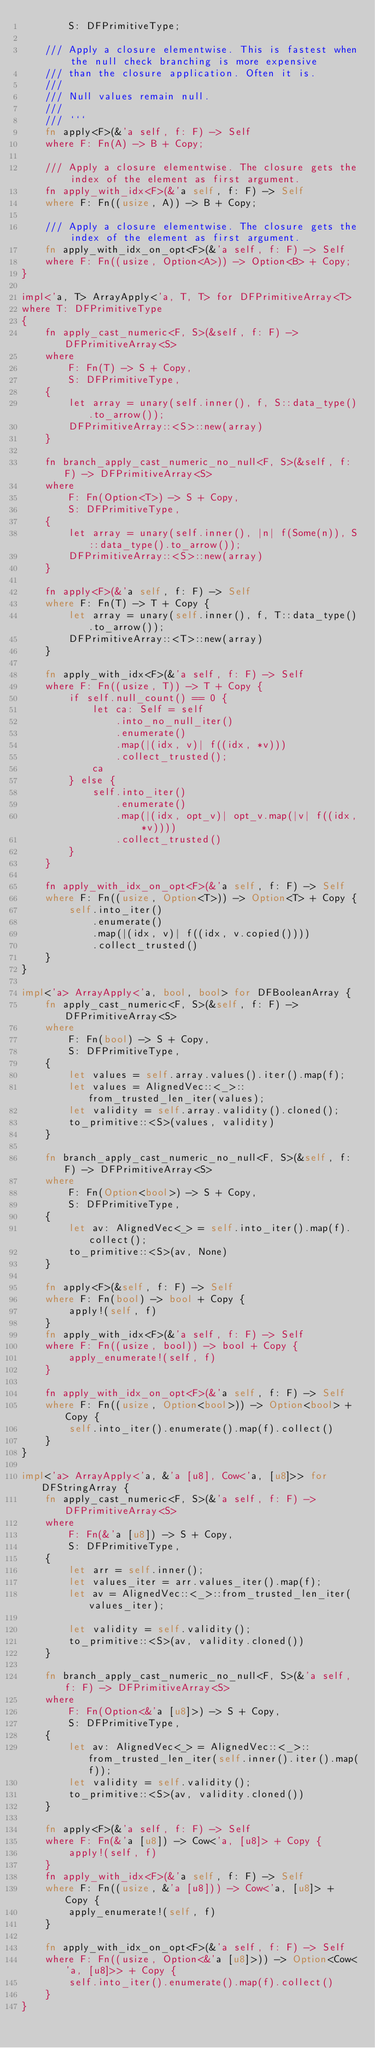<code> <loc_0><loc_0><loc_500><loc_500><_Rust_>        S: DFPrimitiveType;

    /// Apply a closure elementwise. This is fastest when the null check branching is more expensive
    /// than the closure application. Often it is.
    ///
    /// Null values remain null.
    ///
    /// ```
    fn apply<F>(&'a self, f: F) -> Self
    where F: Fn(A) -> B + Copy;

    /// Apply a closure elementwise. The closure gets the index of the element as first argument.
    fn apply_with_idx<F>(&'a self, f: F) -> Self
    where F: Fn((usize, A)) -> B + Copy;

    /// Apply a closure elementwise. The closure gets the index of the element as first argument.
    fn apply_with_idx_on_opt<F>(&'a self, f: F) -> Self
    where F: Fn((usize, Option<A>)) -> Option<B> + Copy;
}

impl<'a, T> ArrayApply<'a, T, T> for DFPrimitiveArray<T>
where T: DFPrimitiveType
{
    fn apply_cast_numeric<F, S>(&self, f: F) -> DFPrimitiveArray<S>
    where
        F: Fn(T) -> S + Copy,
        S: DFPrimitiveType,
    {
        let array = unary(self.inner(), f, S::data_type().to_arrow());
        DFPrimitiveArray::<S>::new(array)
    }

    fn branch_apply_cast_numeric_no_null<F, S>(&self, f: F) -> DFPrimitiveArray<S>
    where
        F: Fn(Option<T>) -> S + Copy,
        S: DFPrimitiveType,
    {
        let array = unary(self.inner(), |n| f(Some(n)), S::data_type().to_arrow());
        DFPrimitiveArray::<S>::new(array)
    }

    fn apply<F>(&'a self, f: F) -> Self
    where F: Fn(T) -> T + Copy {
        let array = unary(self.inner(), f, T::data_type().to_arrow());
        DFPrimitiveArray::<T>::new(array)
    }

    fn apply_with_idx<F>(&'a self, f: F) -> Self
    where F: Fn((usize, T)) -> T + Copy {
        if self.null_count() == 0 {
            let ca: Self = self
                .into_no_null_iter()
                .enumerate()
                .map(|(idx, v)| f((idx, *v)))
                .collect_trusted();
            ca
        } else {
            self.into_iter()
                .enumerate()
                .map(|(idx, opt_v)| opt_v.map(|v| f((idx, *v))))
                .collect_trusted()
        }
    }

    fn apply_with_idx_on_opt<F>(&'a self, f: F) -> Self
    where F: Fn((usize, Option<T>)) -> Option<T> + Copy {
        self.into_iter()
            .enumerate()
            .map(|(idx, v)| f((idx, v.copied())))
            .collect_trusted()
    }
}

impl<'a> ArrayApply<'a, bool, bool> for DFBooleanArray {
    fn apply_cast_numeric<F, S>(&self, f: F) -> DFPrimitiveArray<S>
    where
        F: Fn(bool) -> S + Copy,
        S: DFPrimitiveType,
    {
        let values = self.array.values().iter().map(f);
        let values = AlignedVec::<_>::from_trusted_len_iter(values);
        let validity = self.array.validity().cloned();
        to_primitive::<S>(values, validity)
    }

    fn branch_apply_cast_numeric_no_null<F, S>(&self, f: F) -> DFPrimitiveArray<S>
    where
        F: Fn(Option<bool>) -> S + Copy,
        S: DFPrimitiveType,
    {
        let av: AlignedVec<_> = self.into_iter().map(f).collect();
        to_primitive::<S>(av, None)
    }

    fn apply<F>(&self, f: F) -> Self
    where F: Fn(bool) -> bool + Copy {
        apply!(self, f)
    }
    fn apply_with_idx<F>(&'a self, f: F) -> Self
    where F: Fn((usize, bool)) -> bool + Copy {
        apply_enumerate!(self, f)
    }

    fn apply_with_idx_on_opt<F>(&'a self, f: F) -> Self
    where F: Fn((usize, Option<bool>)) -> Option<bool> + Copy {
        self.into_iter().enumerate().map(f).collect()
    }
}

impl<'a> ArrayApply<'a, &'a [u8], Cow<'a, [u8]>> for DFStringArray {
    fn apply_cast_numeric<F, S>(&'a self, f: F) -> DFPrimitiveArray<S>
    where
        F: Fn(&'a [u8]) -> S + Copy,
        S: DFPrimitiveType,
    {
        let arr = self.inner();
        let values_iter = arr.values_iter().map(f);
        let av = AlignedVec::<_>::from_trusted_len_iter(values_iter);

        let validity = self.validity();
        to_primitive::<S>(av, validity.cloned())
    }

    fn branch_apply_cast_numeric_no_null<F, S>(&'a self, f: F) -> DFPrimitiveArray<S>
    where
        F: Fn(Option<&'a [u8]>) -> S + Copy,
        S: DFPrimitiveType,
    {
        let av: AlignedVec<_> = AlignedVec::<_>::from_trusted_len_iter(self.inner().iter().map(f));
        let validity = self.validity();
        to_primitive::<S>(av, validity.cloned())
    }

    fn apply<F>(&'a self, f: F) -> Self
    where F: Fn(&'a [u8]) -> Cow<'a, [u8]> + Copy {
        apply!(self, f)
    }
    fn apply_with_idx<F>(&'a self, f: F) -> Self
    where F: Fn((usize, &'a [u8])) -> Cow<'a, [u8]> + Copy {
        apply_enumerate!(self, f)
    }

    fn apply_with_idx_on_opt<F>(&'a self, f: F) -> Self
    where F: Fn((usize, Option<&'a [u8]>)) -> Option<Cow<'a, [u8]>> + Copy {
        self.into_iter().enumerate().map(f).collect()
    }
}
</code> 